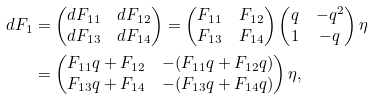Convert formula to latex. <formula><loc_0><loc_0><loc_500><loc_500>d F _ { 1 } & = \begin{pmatrix} d F _ { 1 1 } & d F _ { 1 2 } \\ d F _ { 1 3 } & d F _ { 1 4 } \end{pmatrix} = \begin{pmatrix} F _ { 1 1 } & F _ { 1 2 } \\ F _ { 1 3 } & F _ { 1 4 } \end{pmatrix} \begin{pmatrix} q & - q ^ { 2 } \\ 1 & - q \end{pmatrix} \eta \\ & = \begin{pmatrix} F _ { 1 1 } q + F _ { 1 2 } & - ( F _ { 1 1 } q + F _ { 1 2 } q ) \\ F _ { 1 3 } q + F _ { 1 4 } & - ( F _ { 1 3 } q + F _ { 1 4 } q ) \end{pmatrix} \eta ,</formula> 